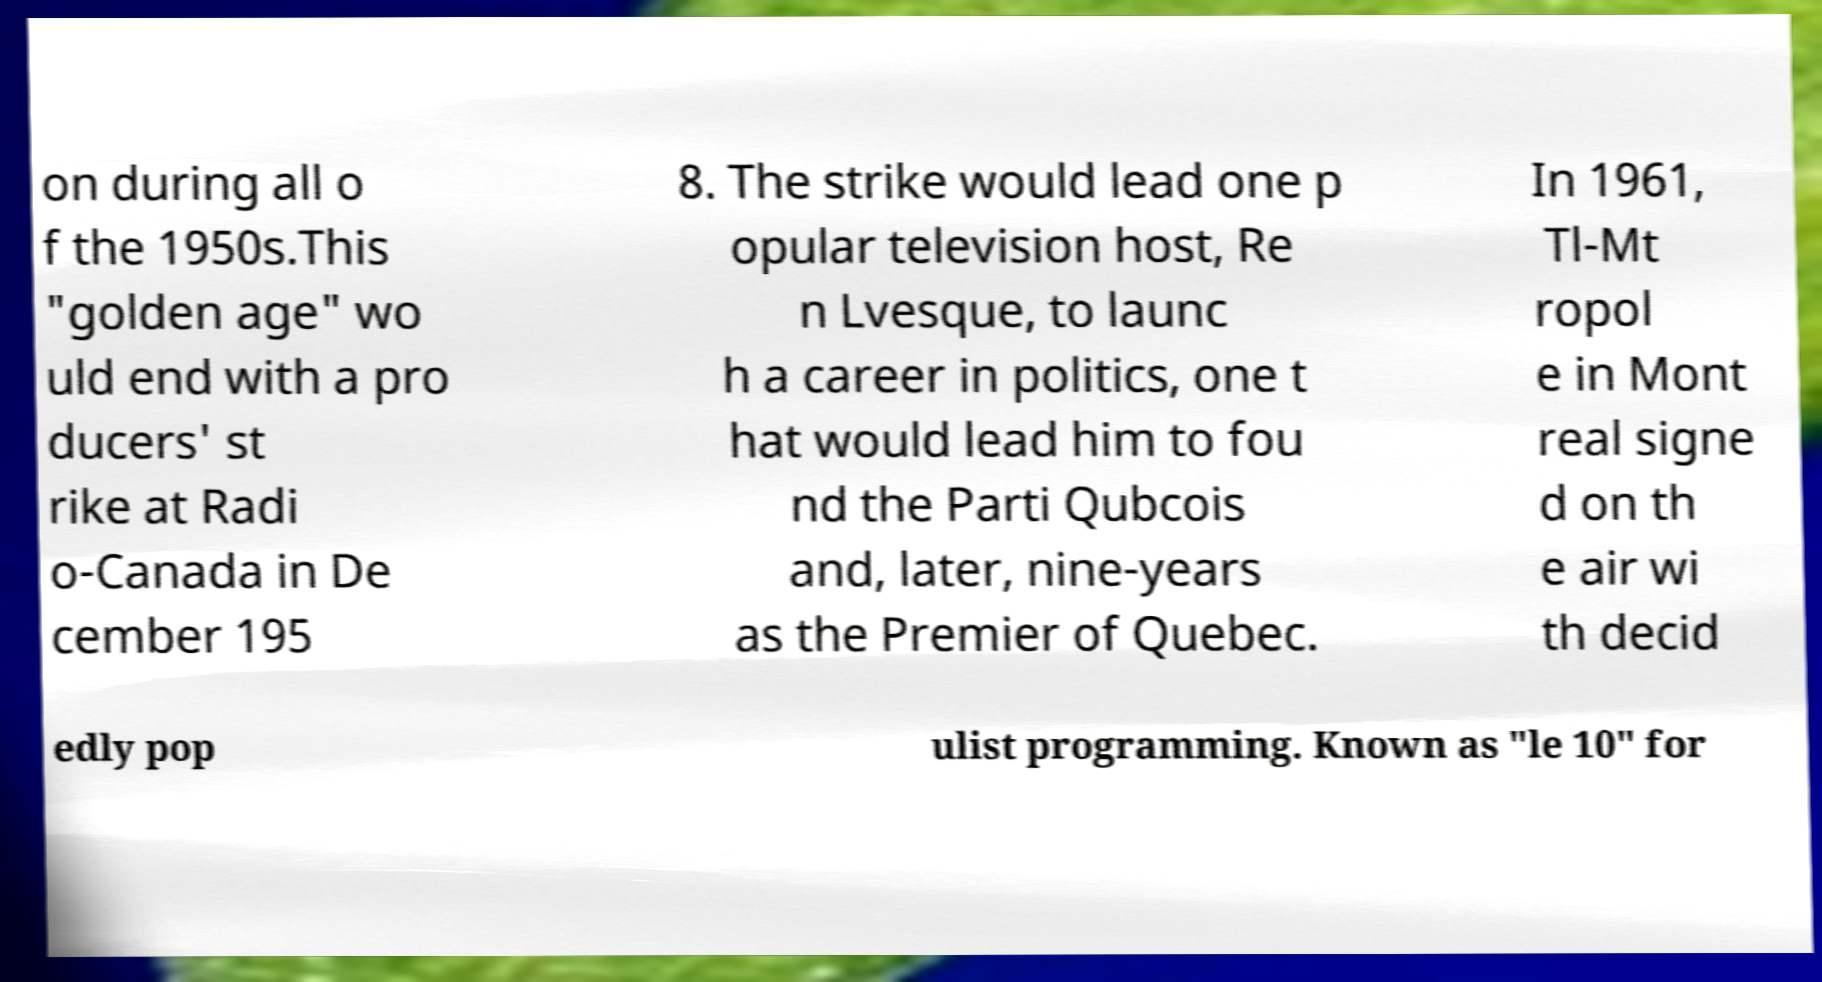Please read and relay the text visible in this image. What does it say? on during all o f the 1950s.This "golden age" wo uld end with a pro ducers' st rike at Radi o-Canada in De cember 195 8. The strike would lead one p opular television host, Re n Lvesque, to launc h a career in politics, one t hat would lead him to fou nd the Parti Qubcois and, later, nine-years as the Premier of Quebec. In 1961, Tl-Mt ropol e in Mont real signe d on th e air wi th decid edly pop ulist programming. Known as "le 10" for 